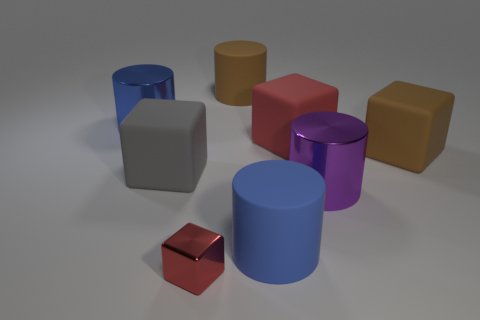Add 2 big purple shiny cylinders. How many objects exist? 10 Add 5 metal cubes. How many metal cubes exist? 6 Subtract 0 blue blocks. How many objects are left? 8 Subtract all tiny red shiny blocks. Subtract all purple metal things. How many objects are left? 6 Add 4 large blocks. How many large blocks are left? 7 